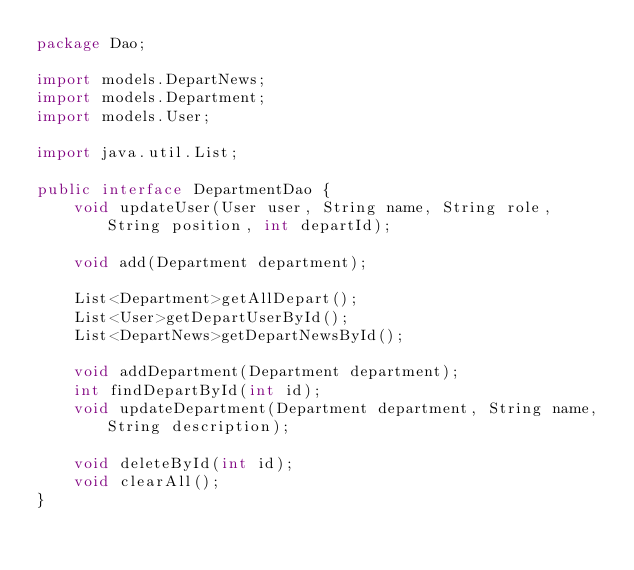Convert code to text. <code><loc_0><loc_0><loc_500><loc_500><_Java_>package Dao;

import models.DepartNews;
import models.Department;
import models.User;

import java.util.List;

public interface DepartmentDao {
    void updateUser(User user, String name, String role, String position, int departId);

    void add(Department department);

    List<Department>getAllDepart();
    List<User>getDepartUserById();
    List<DepartNews>getDepartNewsById();

    void addDepartment(Department department);
    int findDepartById(int id);
    void updateDepartment(Department department, String name, String description);

    void deleteById(int id);
    void clearAll();
}
</code> 